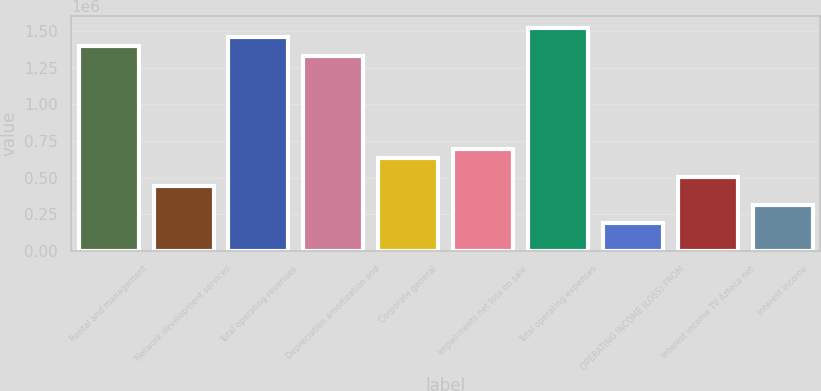<chart> <loc_0><loc_0><loc_500><loc_500><bar_chart><fcel>Rental and management<fcel>Network development services<fcel>Total operating revenues<fcel>Depreciation amortization and<fcel>Corporate general<fcel>Impairments net loss on sale<fcel>Total operating expenses<fcel>OPERATING INCOME (LOSS) FROM<fcel>Interest income TV Azteca net<fcel>Interest income<nl><fcel>1.39724e+06<fcel>444577<fcel>1.46075e+06<fcel>1.33373e+06<fcel>635110<fcel>698621<fcel>1.52426e+06<fcel>190533<fcel>508088<fcel>317555<nl></chart> 